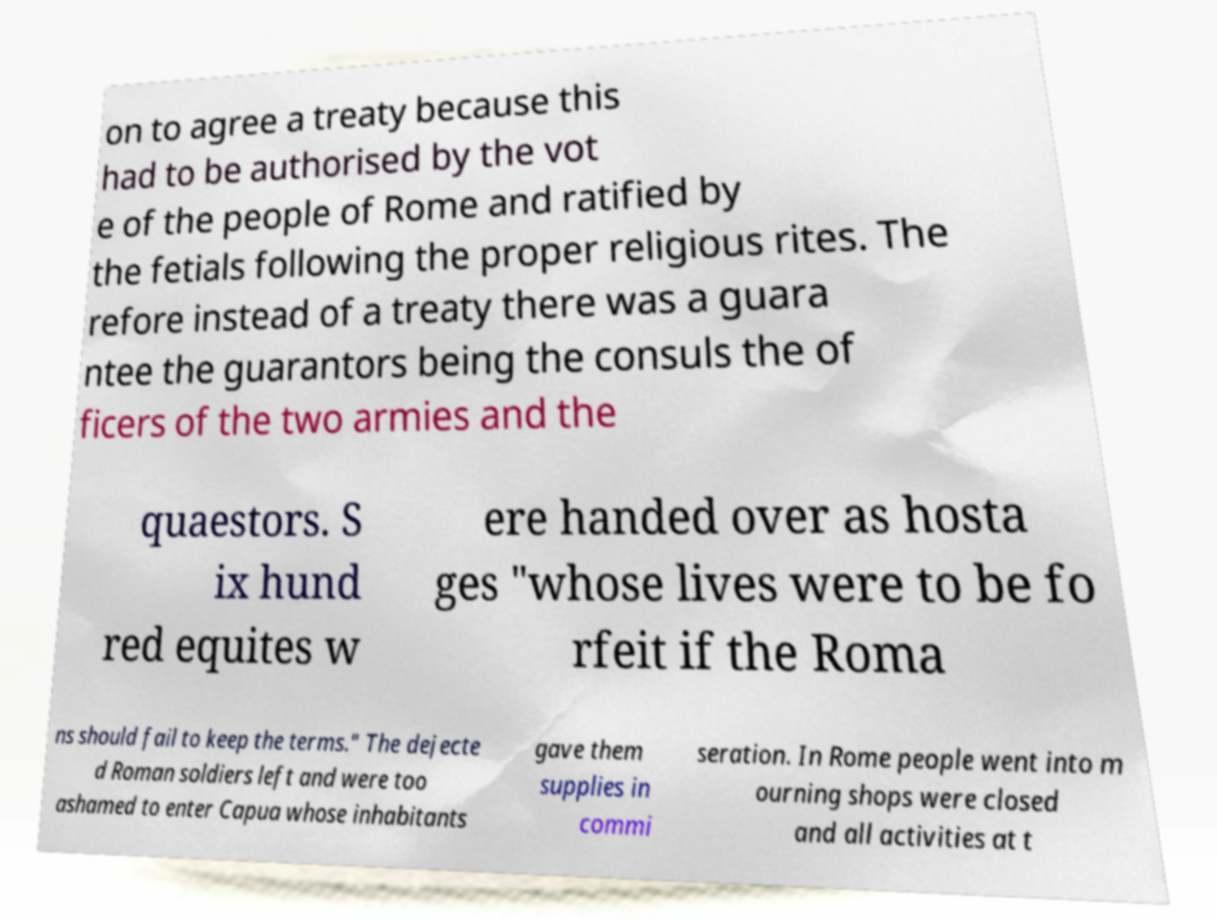What messages or text are displayed in this image? I need them in a readable, typed format. on to agree a treaty because this had to be authorised by the vot e of the people of Rome and ratified by the fetials following the proper religious rites. The refore instead of a treaty there was a guara ntee the guarantors being the consuls the of ficers of the two armies and the quaestors. S ix hund red equites w ere handed over as hosta ges "whose lives were to be fo rfeit if the Roma ns should fail to keep the terms." The dejecte d Roman soldiers left and were too ashamed to enter Capua whose inhabitants gave them supplies in commi seration. In Rome people went into m ourning shops were closed and all activities at t 